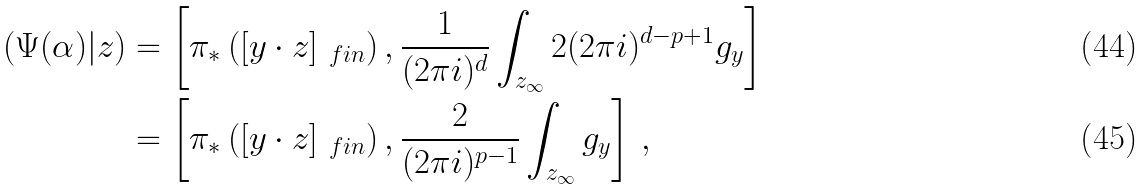Convert formula to latex. <formula><loc_0><loc_0><loc_500><loc_500>( \Psi ( \alpha ) | z ) & = \left [ \pi _ { \ast } \left ( [ y \cdot z ] _ { \ f i n } \right ) , \frac { 1 } { ( 2 \pi i ) ^ { d } } \int _ { z _ { \infty } } 2 ( 2 \pi i ) ^ { d - p + 1 } g _ { y } \right ] \\ & = \left [ \pi _ { \ast } \left ( [ y \cdot z ] _ { \ f i n } \right ) , \frac { 2 } { ( 2 \pi i ) ^ { p - 1 } } \int _ { z _ { \infty } } g _ { y } \right ] \, ,</formula> 